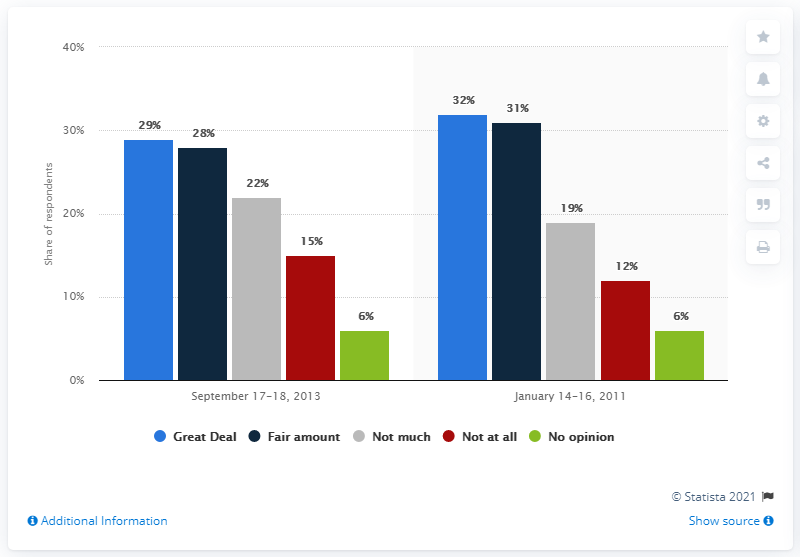List a handful of essential elements in this visual. Green is the color that represents no opinion. The ratio of the longest red bar to the shortest green bar is 2.5, indicating a significant difference in size between the two bars. 